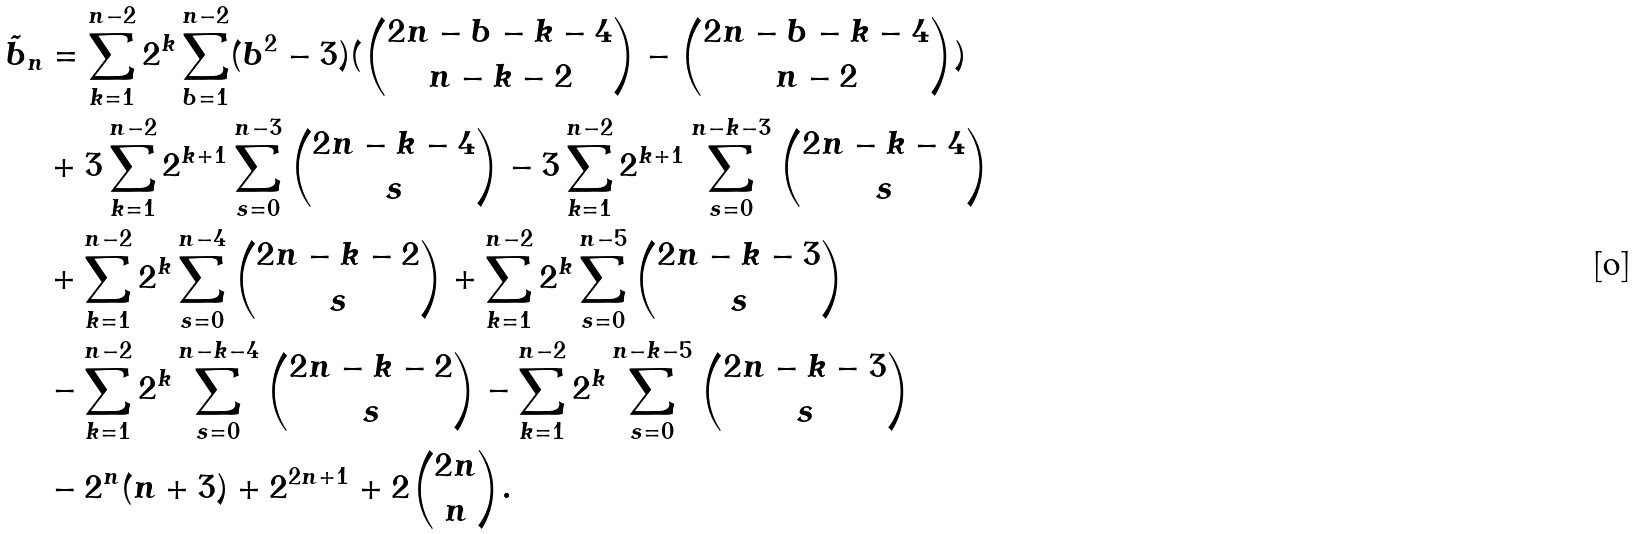<formula> <loc_0><loc_0><loc_500><loc_500>\tilde { b } _ { n } & = \sum _ { k = 1 } ^ { n - 2 } 2 ^ { k } \sum _ { b = 1 } ^ { n - 2 } ( b ^ { 2 } - 3 ) ( \binom { 2 n - b - k - 4 } { n - k - 2 } - \binom { 2 n - b - k - 4 } { n - 2 } ) \\ & + 3 \sum _ { k = 1 } ^ { n - 2 } 2 ^ { k + 1 } \sum _ { s = 0 } ^ { n - 3 } \binom { 2 n - k - 4 } { s } - 3 \sum _ { k = 1 } ^ { n - 2 } 2 ^ { k + 1 } \sum _ { s = 0 } ^ { n - k - 3 } \binom { 2 n - k - 4 } { s } \\ & + \sum _ { k = 1 } ^ { n - 2 } 2 ^ { k } \sum _ { s = 0 } ^ { n - 4 } \binom { 2 n - k - 2 } { s } + \sum _ { k = 1 } ^ { n - 2 } 2 ^ { k } \sum _ { s = 0 } ^ { n - 5 } \binom { 2 n - k - 3 } { s } \\ & - \sum _ { k = 1 } ^ { n - 2 } 2 ^ { k } \sum _ { s = 0 } ^ { n - k - 4 } \binom { 2 n - k - 2 } { s } - \sum _ { k = 1 } ^ { n - 2 } 2 ^ { k } \sum _ { s = 0 } ^ { n - k - 5 } \binom { 2 n - k - 3 } { s } \\ & - 2 ^ { n } ( n + 3 ) + 2 ^ { 2 n + 1 } + 2 \binom { 2 n } { n } . \\</formula> 